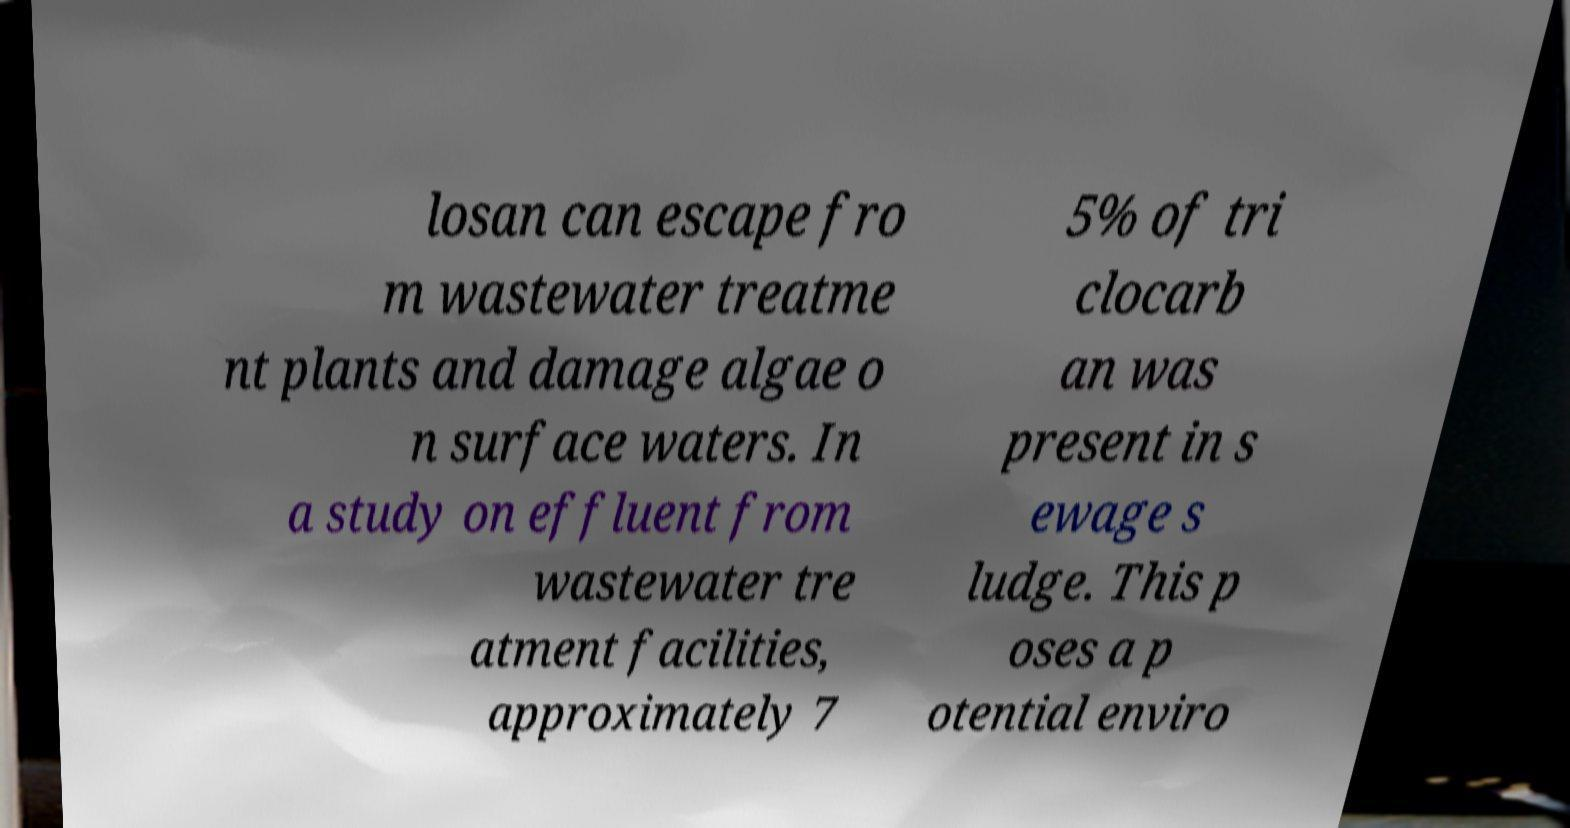What messages or text are displayed in this image? I need them in a readable, typed format. losan can escape fro m wastewater treatme nt plants and damage algae o n surface waters. In a study on effluent from wastewater tre atment facilities, approximately 7 5% of tri clocarb an was present in s ewage s ludge. This p oses a p otential enviro 